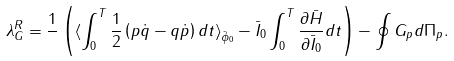<formula> <loc_0><loc_0><loc_500><loc_500>\lambda _ { G } ^ { R } = \frac { 1 } { } \left ( \langle \int _ { 0 } ^ { T } \frac { 1 } { 2 } \left ( p \dot { q } - q \dot { p } \right ) d t \rangle _ { \bar { \phi } _ { 0 } } - \bar { I } _ { 0 } \int _ { 0 } ^ { T } \frac { \partial \bar { H } } { \partial \bar { I } _ { 0 } } d t \right ) - \oint G _ { p } d \Pi _ { p } .</formula> 